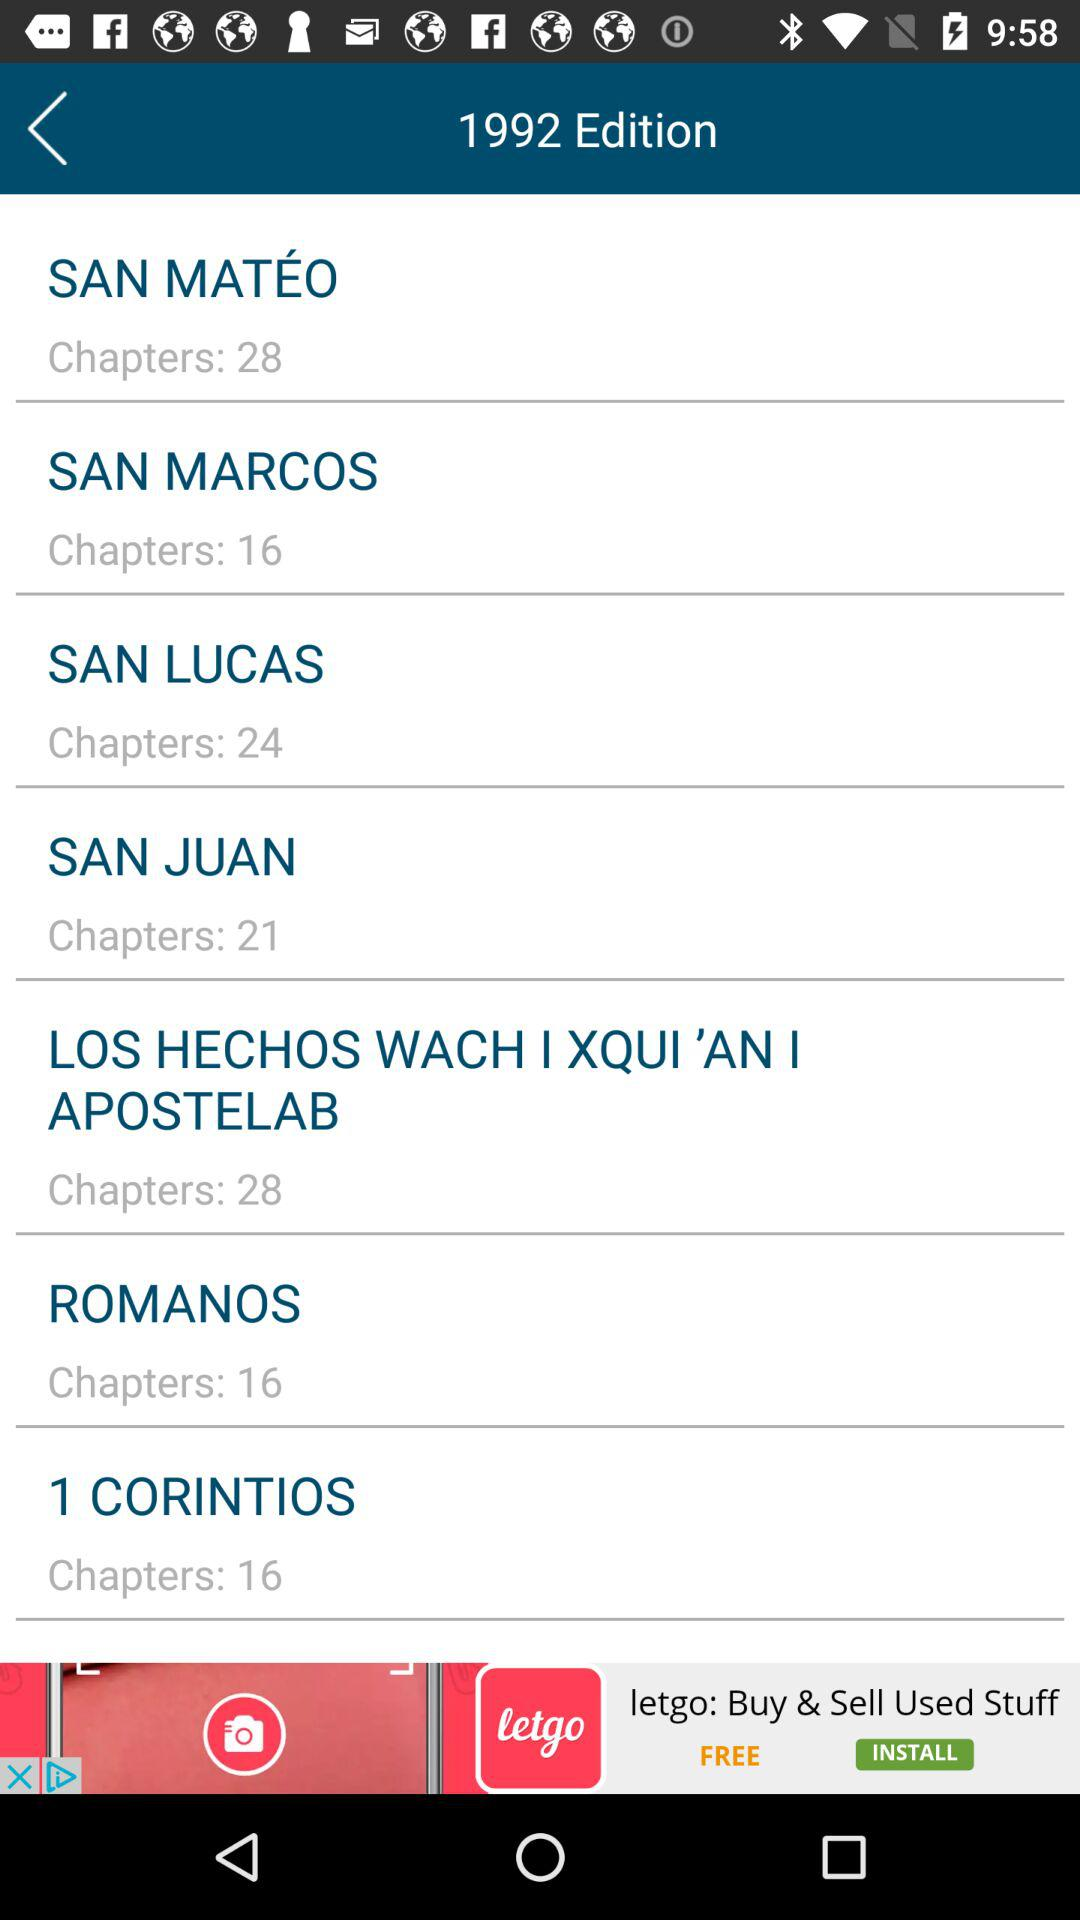How many chapters are there in ROMANOS? There are 16 chapters in "ROMANOS". 